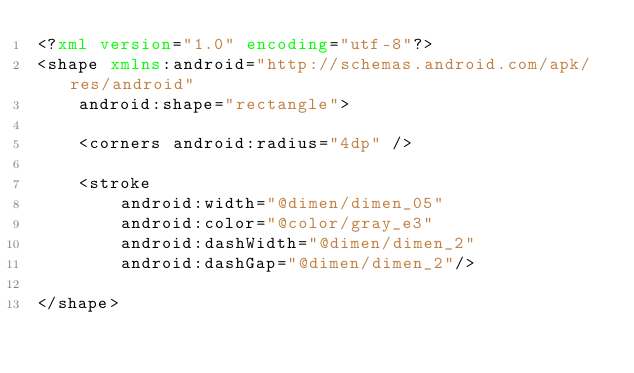<code> <loc_0><loc_0><loc_500><loc_500><_XML_><?xml version="1.0" encoding="utf-8"?>
<shape xmlns:android="http://schemas.android.com/apk/res/android"
    android:shape="rectangle">

    <corners android:radius="4dp" />

    <stroke
        android:width="@dimen/dimen_05"
        android:color="@color/gray_e3"
        android:dashWidth="@dimen/dimen_2"
        android:dashGap="@dimen/dimen_2"/>

</shape></code> 